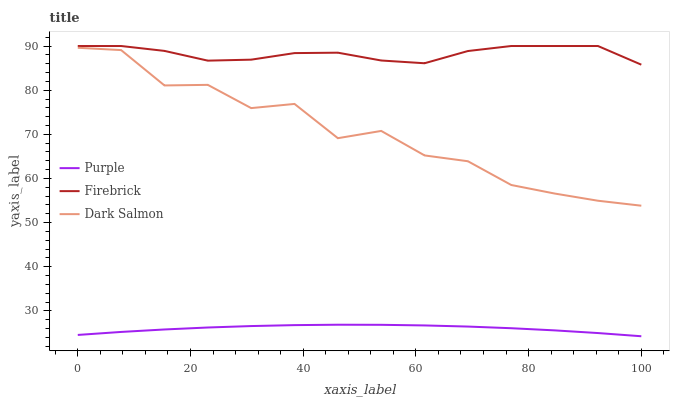Does Purple have the minimum area under the curve?
Answer yes or no. Yes. Does Firebrick have the maximum area under the curve?
Answer yes or no. Yes. Does Dark Salmon have the minimum area under the curve?
Answer yes or no. No. Does Dark Salmon have the maximum area under the curve?
Answer yes or no. No. Is Purple the smoothest?
Answer yes or no. Yes. Is Dark Salmon the roughest?
Answer yes or no. Yes. Is Firebrick the smoothest?
Answer yes or no. No. Is Firebrick the roughest?
Answer yes or no. No. Does Purple have the lowest value?
Answer yes or no. Yes. Does Dark Salmon have the lowest value?
Answer yes or no. No. Does Firebrick have the highest value?
Answer yes or no. Yes. Does Dark Salmon have the highest value?
Answer yes or no. No. Is Purple less than Dark Salmon?
Answer yes or no. Yes. Is Firebrick greater than Purple?
Answer yes or no. Yes. Does Purple intersect Dark Salmon?
Answer yes or no. No. 